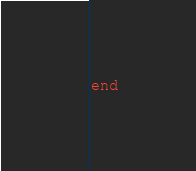<code> <loc_0><loc_0><loc_500><loc_500><_Ruby_>end</code> 